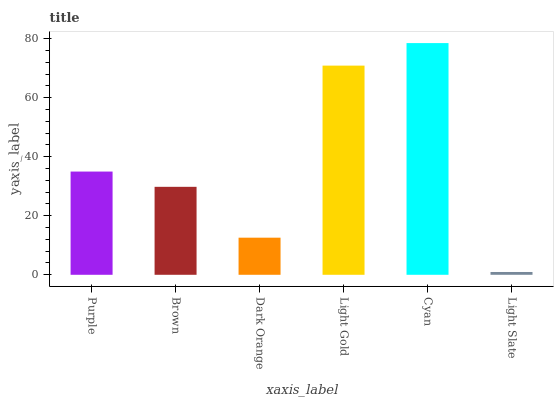Is Light Slate the minimum?
Answer yes or no. Yes. Is Cyan the maximum?
Answer yes or no. Yes. Is Brown the minimum?
Answer yes or no. No. Is Brown the maximum?
Answer yes or no. No. Is Purple greater than Brown?
Answer yes or no. Yes. Is Brown less than Purple?
Answer yes or no. Yes. Is Brown greater than Purple?
Answer yes or no. No. Is Purple less than Brown?
Answer yes or no. No. Is Purple the high median?
Answer yes or no. Yes. Is Brown the low median?
Answer yes or no. Yes. Is Light Gold the high median?
Answer yes or no. No. Is Purple the low median?
Answer yes or no. No. 